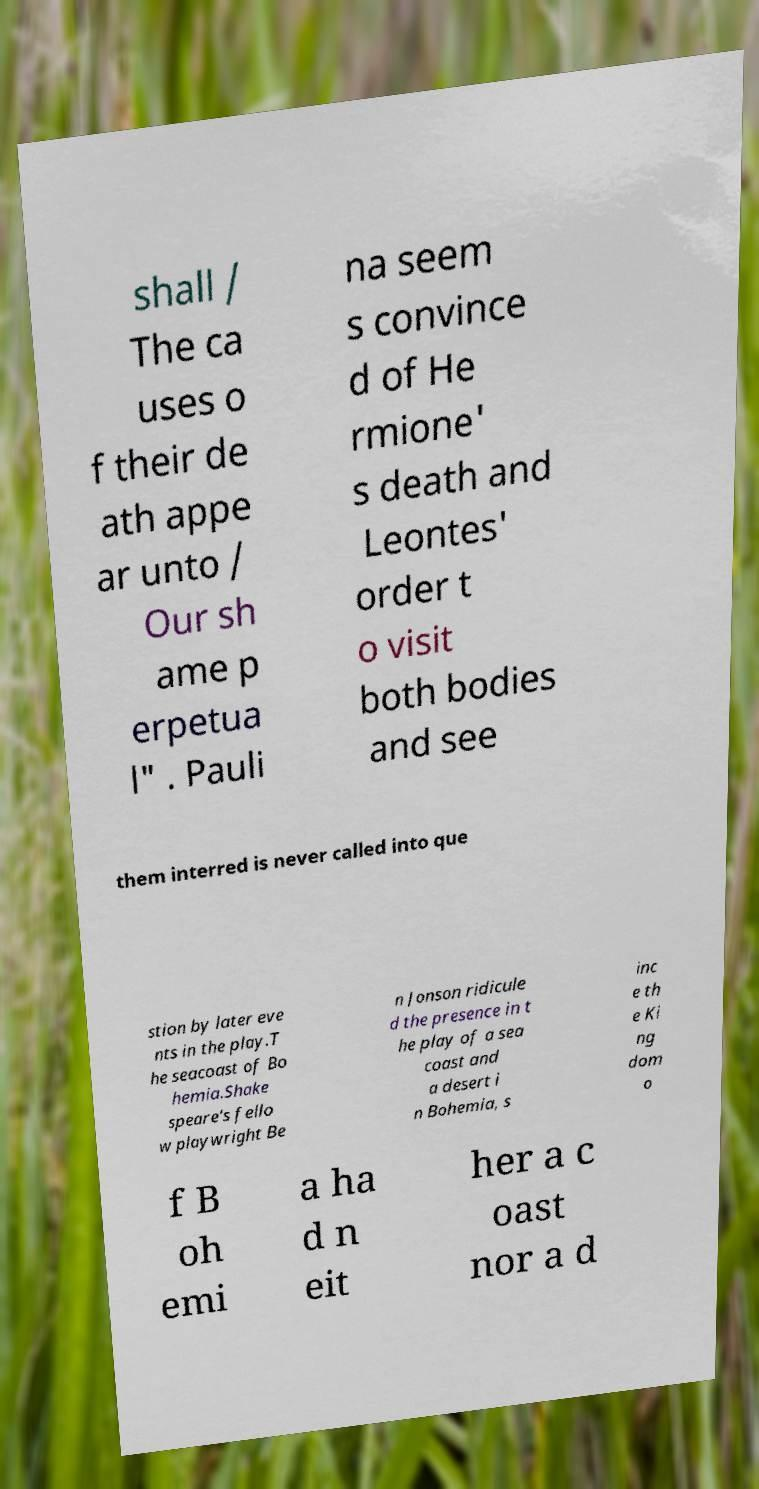There's text embedded in this image that I need extracted. Can you transcribe it verbatim? shall / The ca uses o f their de ath appe ar unto / Our sh ame p erpetua l" . Pauli na seem s convince d of He rmione' s death and Leontes' order t o visit both bodies and see them interred is never called into que stion by later eve nts in the play.T he seacoast of Bo hemia.Shake speare's fello w playwright Be n Jonson ridicule d the presence in t he play of a sea coast and a desert i n Bohemia, s inc e th e Ki ng dom o f B oh emi a ha d n eit her a c oast nor a d 